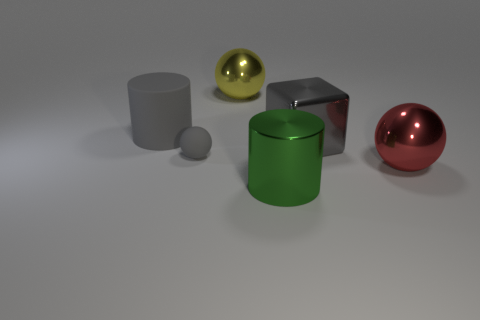Add 3 large red objects. How many objects exist? 9 Subtract all cubes. How many objects are left? 5 Subtract 0 cyan cubes. How many objects are left? 6 Subtract all large metal objects. Subtract all large green metal spheres. How many objects are left? 2 Add 4 large red shiny objects. How many large red shiny objects are left? 5 Add 6 red metallic things. How many red metallic things exist? 7 